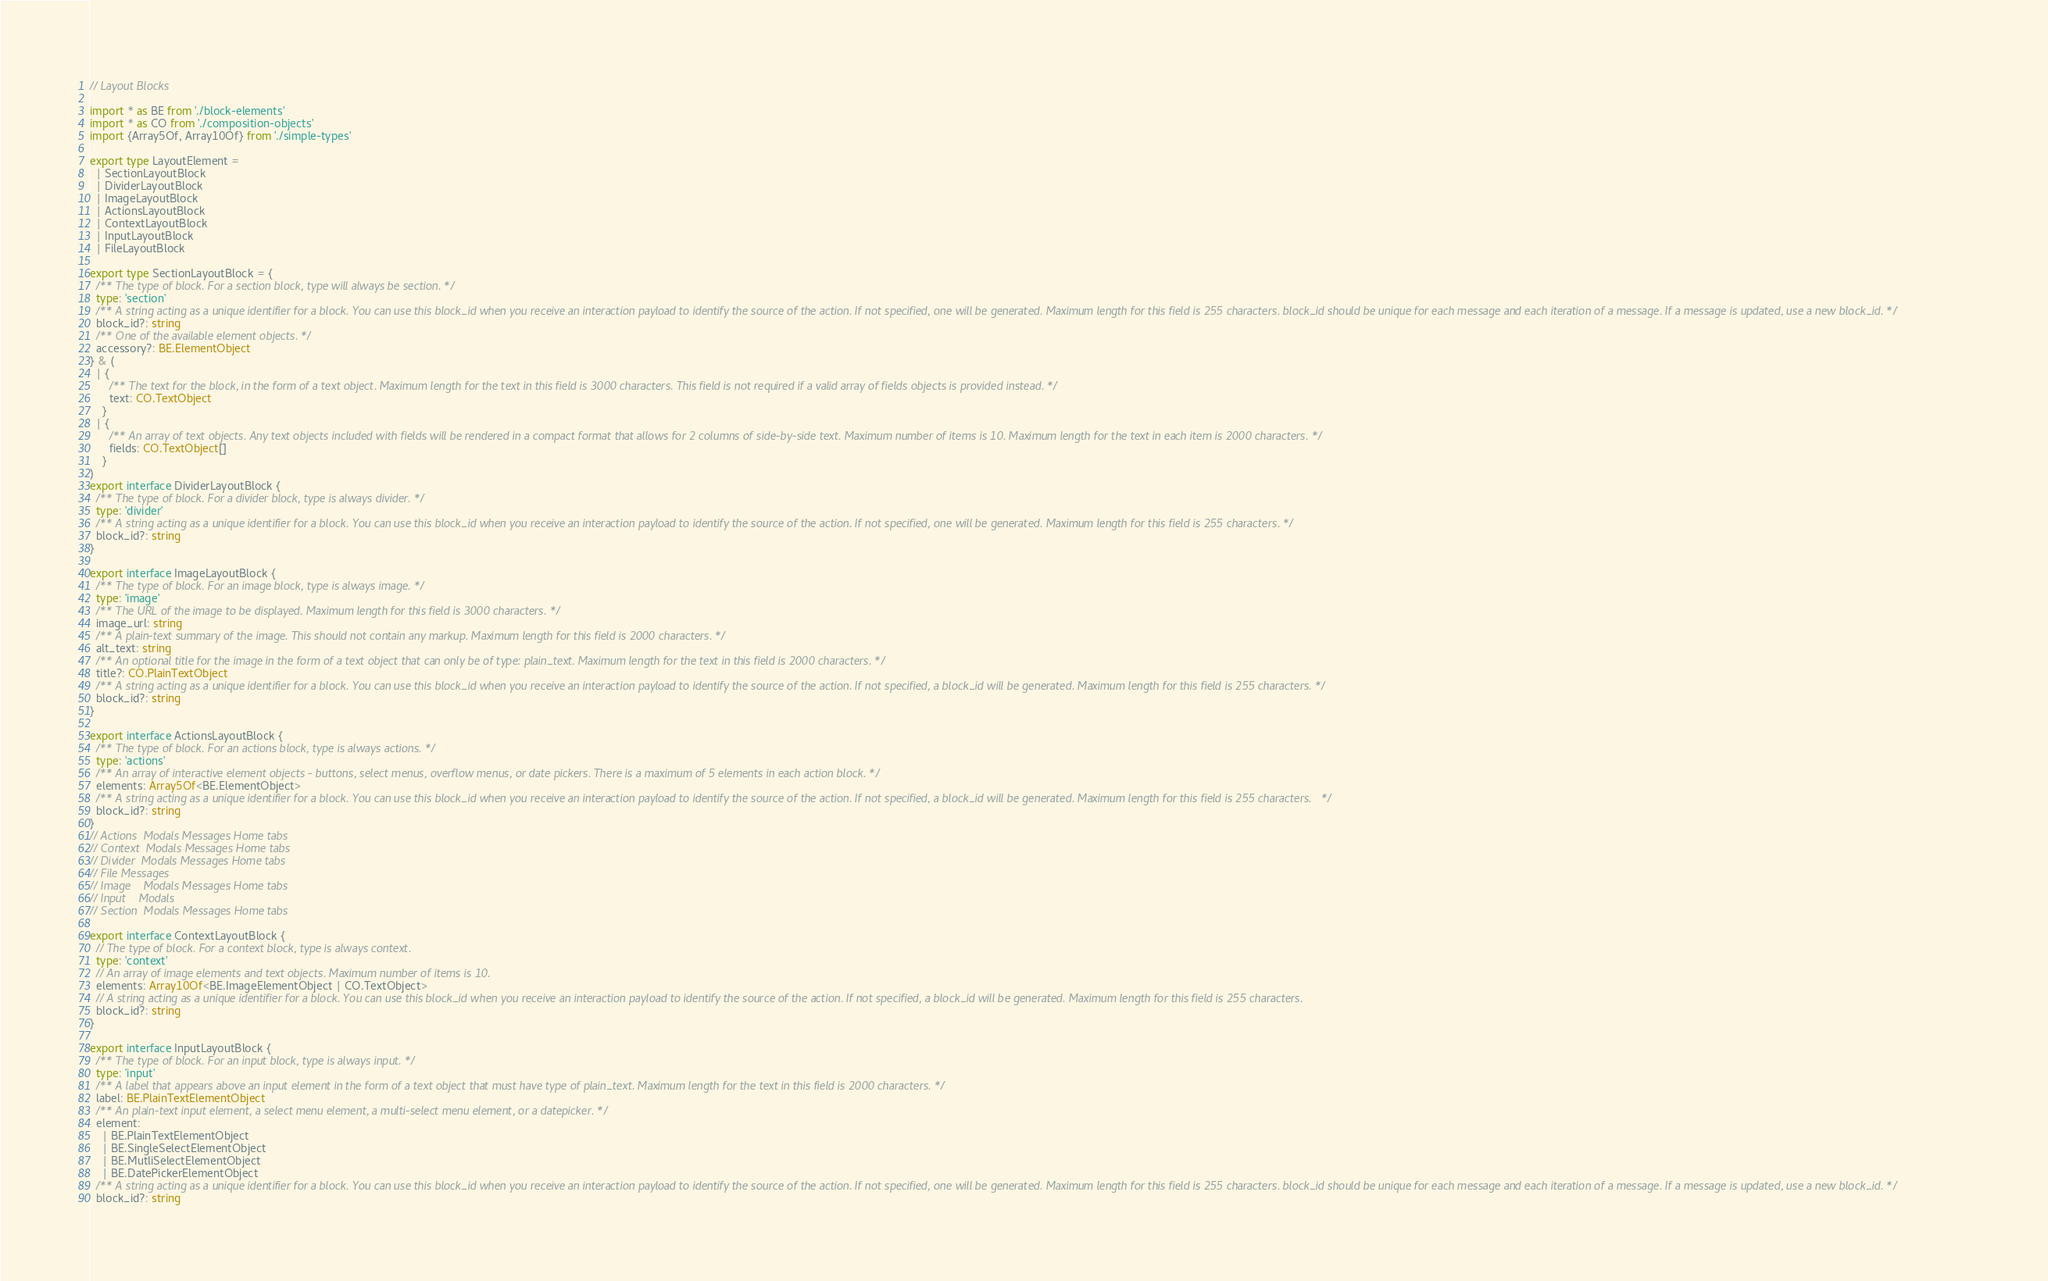<code> <loc_0><loc_0><loc_500><loc_500><_TypeScript_>// Layout Blocks

import * as BE from './block-elements'
import * as CO from './composition-objects'
import {Array5Of, Array10Of} from './simple-types'

export type LayoutElement =
  | SectionLayoutBlock
  | DividerLayoutBlock
  | ImageLayoutBlock
  | ActionsLayoutBlock
  | ContextLayoutBlock
  | InputLayoutBlock
  | FileLayoutBlock

export type SectionLayoutBlock = {
  /** The type of block. For a section block, type will always be section. */
  type: 'section'
  /** A string acting as a unique identifier for a block. You can use this block_id when you receive an interaction payload to identify the source of the action. If not specified, one will be generated. Maximum length for this field is 255 characters. block_id should be unique for each message and each iteration of a message. If a message is updated, use a new block_id. */
  block_id?: string
  /** One of the available element objects. */
  accessory?: BE.ElementObject
} & (
  | {
      /** The text for the block, in the form of a text object. Maximum length for the text in this field is 3000 characters. This field is not required if a valid array of fields objects is provided instead. */
      text: CO.TextObject
    }
  | {
      /** An array of text objects. Any text objects included with fields will be rendered in a compact format that allows for 2 columns of side-by-side text. Maximum number of items is 10. Maximum length for the text in each item is 2000 characters. */
      fields: CO.TextObject[]
    }
)
export interface DividerLayoutBlock {
  /** The type of block. For a divider block, type is always divider. */
  type: 'divider'
  /** A string acting as a unique identifier for a block. You can use this block_id when you receive an interaction payload to identify the source of the action. If not specified, one will be generated. Maximum length for this field is 255 characters. */
  block_id?: string
}

export interface ImageLayoutBlock {
  /** The type of block. For an image block, type is always image. */
  type: 'image'
  /** The URL of the image to be displayed. Maximum length for this field is 3000 characters. */
  image_url: string
  /** A plain-text summary of the image. This should not contain any markup. Maximum length for this field is 2000 characters. */
  alt_text: string
  /** An optional title for the image in the form of a text object that can only be of type: plain_text. Maximum length for the text in this field is 2000 characters. */
  title?: CO.PlainTextObject
  /** A string acting as a unique identifier for a block. You can use this block_id when you receive an interaction payload to identify the source of the action. If not specified, a block_id will be generated. Maximum length for this field is 255 characters. */
  block_id?: string
}

export interface ActionsLayoutBlock {
  /**	The type of block. For an actions block, type is always actions. */
  type: 'actions'
  /**	An array of interactive element objects - buttons, select menus, overflow menus, or date pickers. There is a maximum of 5 elements in each action block. */
  elements: Array5Of<BE.ElementObject>
  /**	A string acting as a unique identifier for a block. You can use this block_id when you receive an interaction payload to identify the source of the action. If not specified, a block_id will be generated. Maximum length for this field is 255 characters.   */
  block_id?: string
}
// Actions	Modals Messages Home tabs
// Context	Modals Messages Home tabs
// Divider	Modals Messages Home tabs
// File	Messages
// Image	Modals Messages Home tabs
// Input	Modals
// Section	Modals Messages Home tabs

export interface ContextLayoutBlock {
  // The type of block. For a context block, type is always context.
  type: 'context'
  // An array of image elements and text objects. Maximum number of items is 10.
  elements: Array10Of<BE.ImageElementObject | CO.TextObject>
  // A string acting as a unique identifier for a block. You can use this block_id when you receive an interaction payload to identify the source of the action. If not specified, a block_id will be generated. Maximum length for this field is 255 characters.
  block_id?: string
}

export interface InputLayoutBlock {
  /** The type of block. For an input block, type is always input. */
  type: 'input'
  /** A label that appears above an input element in the form of a text object that must have type of plain_text. Maximum length for the text in this field is 2000 characters. */
  label: BE.PlainTextElementObject
  /** An plain-text input element, a select menu element, a multi-select menu element, or a datepicker. */
  element:
    | BE.PlainTextElementObject
    | BE.SingleSelectElementObject
    | BE.MutliSelectElementObject
    | BE.DatePickerElementObject
  /** A string acting as a unique identifier for a block. You can use this block_id when you receive an interaction payload to identify the source of the action. If not specified, one will be generated. Maximum length for this field is 255 characters. block_id should be unique for each message and each iteration of a message. If a message is updated, use a new block_id. */
  block_id?: string</code> 